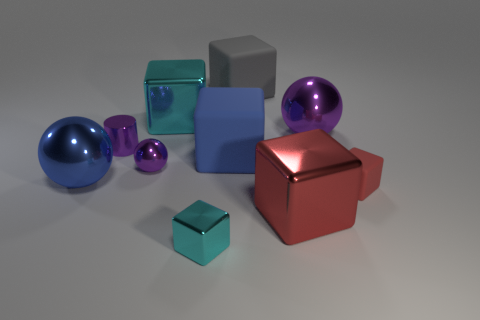Are there any other things that have the same shape as the tiny cyan object?
Your answer should be very brief. Yes. How many objects are either matte objects behind the big purple object or big gray matte things?
Offer a very short reply. 1. Is the shape of the small cyan shiny thing the same as the gray object?
Your response must be concise. Yes. What number of other things are there of the same size as the blue metallic object?
Make the answer very short. 5. What color is the tiny cylinder?
Keep it short and to the point. Purple. What number of small things are either cyan metallic objects or purple balls?
Give a very brief answer. 2. Does the cyan object that is in front of the large blue metallic object have the same size as the purple ball right of the large red block?
Keep it short and to the point. No. What size is the gray thing that is the same shape as the small red thing?
Provide a short and direct response. Large. Are there more purple cylinders in front of the purple cylinder than blue shiny objects to the left of the tiny cyan metallic object?
Your response must be concise. No. There is a block that is to the left of the blue rubber cube and behind the blue metal object; what is its material?
Your answer should be very brief. Metal. 